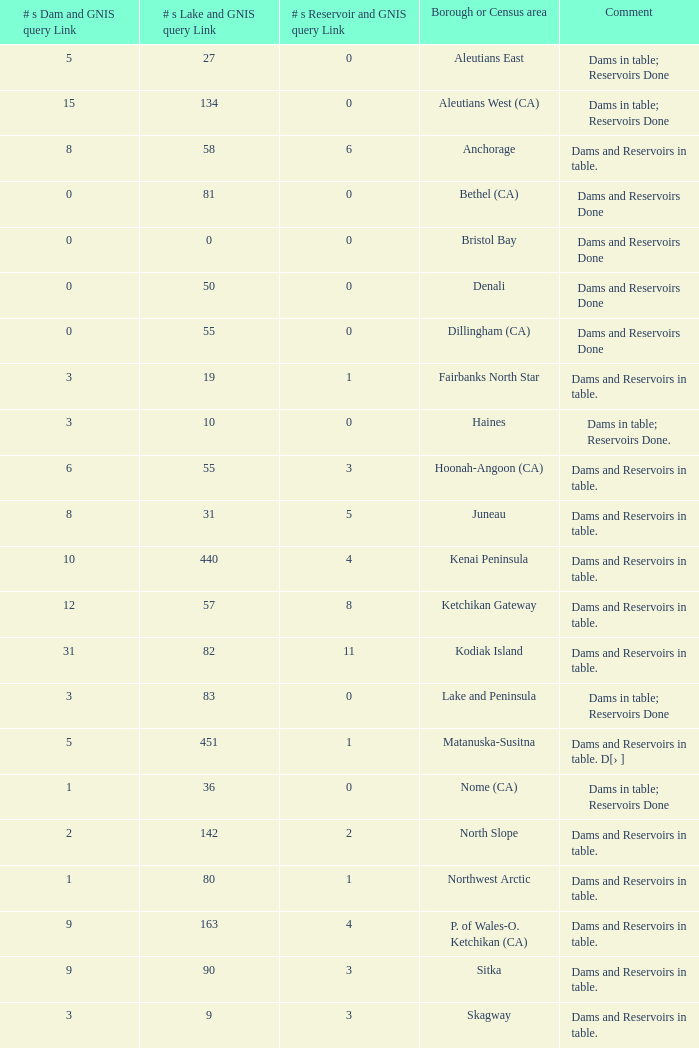Name the most numbers dam and gnis query link for borough or census area for fairbanks north star 3.0. 